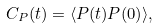<formula> <loc_0><loc_0><loc_500><loc_500>C _ { P } ( t ) = \langle P ( t ) P ( 0 ) \rangle ,</formula> 